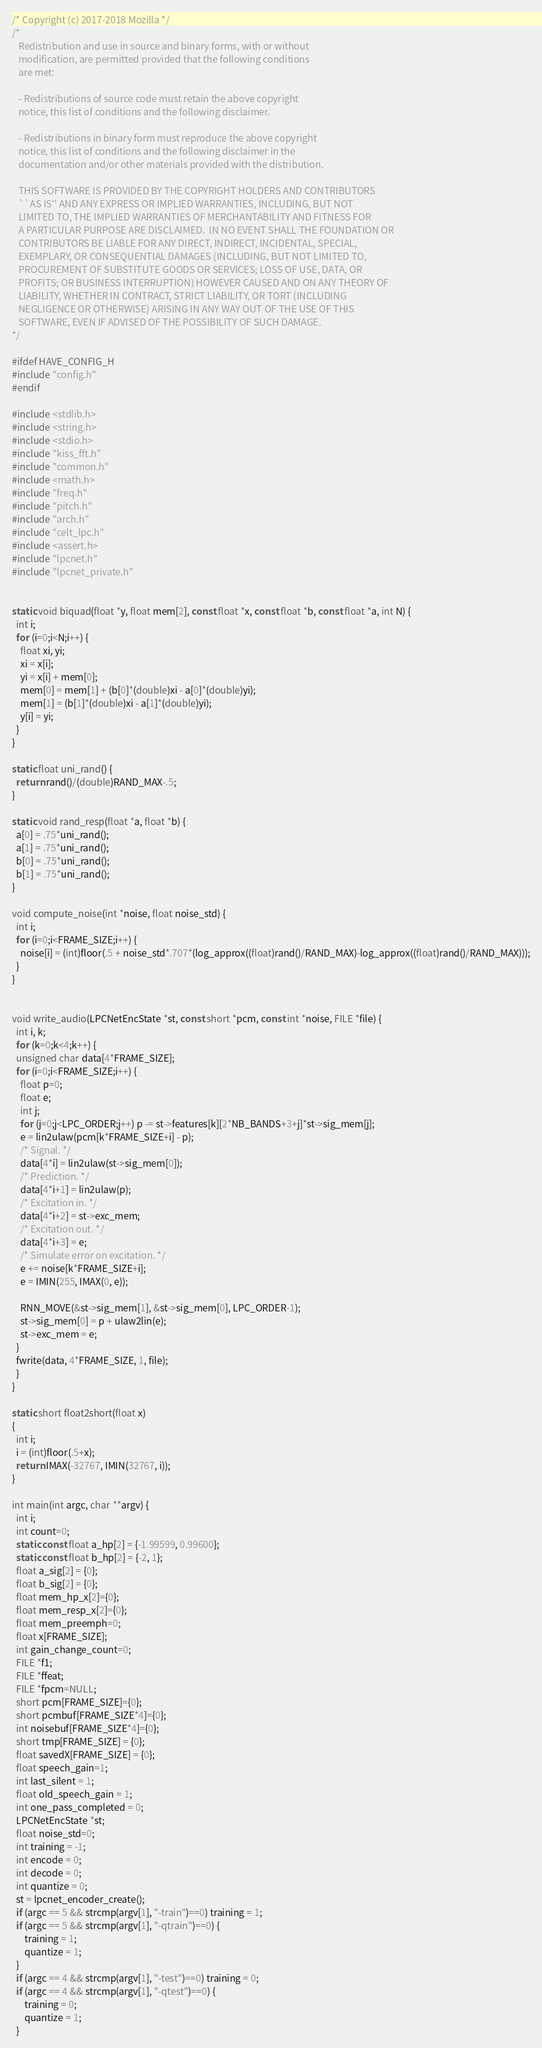Convert code to text. <code><loc_0><loc_0><loc_500><loc_500><_C_>/* Copyright (c) 2017-2018 Mozilla */
/*
   Redistribution and use in source and binary forms, with or without
   modification, are permitted provided that the following conditions
   are met:

   - Redistributions of source code must retain the above copyright
   notice, this list of conditions and the following disclaimer.

   - Redistributions in binary form must reproduce the above copyright
   notice, this list of conditions and the following disclaimer in the
   documentation and/or other materials provided with the distribution.

   THIS SOFTWARE IS PROVIDED BY THE COPYRIGHT HOLDERS AND CONTRIBUTORS
   ``AS IS'' AND ANY EXPRESS OR IMPLIED WARRANTIES, INCLUDING, BUT NOT
   LIMITED TO, THE IMPLIED WARRANTIES OF MERCHANTABILITY AND FITNESS FOR
   A PARTICULAR PURPOSE ARE DISCLAIMED.  IN NO EVENT SHALL THE FOUNDATION OR
   CONTRIBUTORS BE LIABLE FOR ANY DIRECT, INDIRECT, INCIDENTAL, SPECIAL,
   EXEMPLARY, OR CONSEQUENTIAL DAMAGES (INCLUDING, BUT NOT LIMITED TO,
   PROCUREMENT OF SUBSTITUTE GOODS OR SERVICES; LOSS OF USE, DATA, OR
   PROFITS; OR BUSINESS INTERRUPTION) HOWEVER CAUSED AND ON ANY THEORY OF
   LIABILITY, WHETHER IN CONTRACT, STRICT LIABILITY, OR TORT (INCLUDING
   NEGLIGENCE OR OTHERWISE) ARISING IN ANY WAY OUT OF THE USE OF THIS
   SOFTWARE, EVEN IF ADVISED OF THE POSSIBILITY OF SUCH DAMAGE.
*/

#ifdef HAVE_CONFIG_H
#include "config.h"
#endif

#include <stdlib.h>
#include <string.h>
#include <stdio.h>
#include "kiss_fft.h"
#include "common.h"
#include <math.h>
#include "freq.h"
#include "pitch.h"
#include "arch.h"
#include "celt_lpc.h"
#include <assert.h>
#include "lpcnet.h"
#include "lpcnet_private.h"


static void biquad(float *y, float mem[2], const float *x, const float *b, const float *a, int N) {
  int i;
  for (i=0;i<N;i++) {
    float xi, yi;
    xi = x[i];
    yi = x[i] + mem[0];
    mem[0] = mem[1] + (b[0]*(double)xi - a[0]*(double)yi);
    mem[1] = (b[1]*(double)xi - a[1]*(double)yi);
    y[i] = yi;
  }
}

static float uni_rand() {
  return rand()/(double)RAND_MAX-.5;
}

static void rand_resp(float *a, float *b) {
  a[0] = .75*uni_rand();
  a[1] = .75*uni_rand();
  b[0] = .75*uni_rand();
  b[1] = .75*uni_rand();
}

void compute_noise(int *noise, float noise_std) {
  int i;
  for (i=0;i<FRAME_SIZE;i++) {
    noise[i] = (int)floor(.5 + noise_std*.707*(log_approx((float)rand()/RAND_MAX)-log_approx((float)rand()/RAND_MAX)));
  }
}


void write_audio(LPCNetEncState *st, const short *pcm, const int *noise, FILE *file) {
  int i, k;
  for (k=0;k<4;k++) {
  unsigned char data[4*FRAME_SIZE];
  for (i=0;i<FRAME_SIZE;i++) {
    float p=0;
    float e;
    int j;
    for (j=0;j<LPC_ORDER;j++) p -= st->features[k][2*NB_BANDS+3+j]*st->sig_mem[j];
    e = lin2ulaw(pcm[k*FRAME_SIZE+i] - p);
    /* Signal. */
    data[4*i] = lin2ulaw(st->sig_mem[0]);
    /* Prediction. */
    data[4*i+1] = lin2ulaw(p);
    /* Excitation in. */
    data[4*i+2] = st->exc_mem;
    /* Excitation out. */
    data[4*i+3] = e;
    /* Simulate error on excitation. */
    e += noise[k*FRAME_SIZE+i];
    e = IMIN(255, IMAX(0, e));
    
    RNN_MOVE(&st->sig_mem[1], &st->sig_mem[0], LPC_ORDER-1);
    st->sig_mem[0] = p + ulaw2lin(e);
    st->exc_mem = e;
  }
  fwrite(data, 4*FRAME_SIZE, 1, file);
  }
}

static short float2short(float x)
{
  int i;
  i = (int)floor(.5+x);
  return IMAX(-32767, IMIN(32767, i));
}

int main(int argc, char **argv) {
  int i;
  int count=0;
  static const float a_hp[2] = {-1.99599, 0.99600};
  static const float b_hp[2] = {-2, 1};
  float a_sig[2] = {0};
  float b_sig[2] = {0};
  float mem_hp_x[2]={0};
  float mem_resp_x[2]={0};
  float mem_preemph=0;
  float x[FRAME_SIZE];
  int gain_change_count=0;
  FILE *f1;
  FILE *ffeat;
  FILE *fpcm=NULL;
  short pcm[FRAME_SIZE]={0};
  short pcmbuf[FRAME_SIZE*4]={0};
  int noisebuf[FRAME_SIZE*4]={0};
  short tmp[FRAME_SIZE] = {0};
  float savedX[FRAME_SIZE] = {0};
  float speech_gain=1;
  int last_silent = 1;
  float old_speech_gain = 1;
  int one_pass_completed = 0;
  LPCNetEncState *st;
  float noise_std=0;
  int training = -1;
  int encode = 0;
  int decode = 0;
  int quantize = 0;
  st = lpcnet_encoder_create();
  if (argc == 5 && strcmp(argv[1], "-train")==0) training = 1;
  if (argc == 5 && strcmp(argv[1], "-qtrain")==0) {
      training = 1;
      quantize = 1;
  }
  if (argc == 4 && strcmp(argv[1], "-test")==0) training = 0;
  if (argc == 4 && strcmp(argv[1], "-qtest")==0) {
      training = 0;
      quantize = 1;
  }</code> 